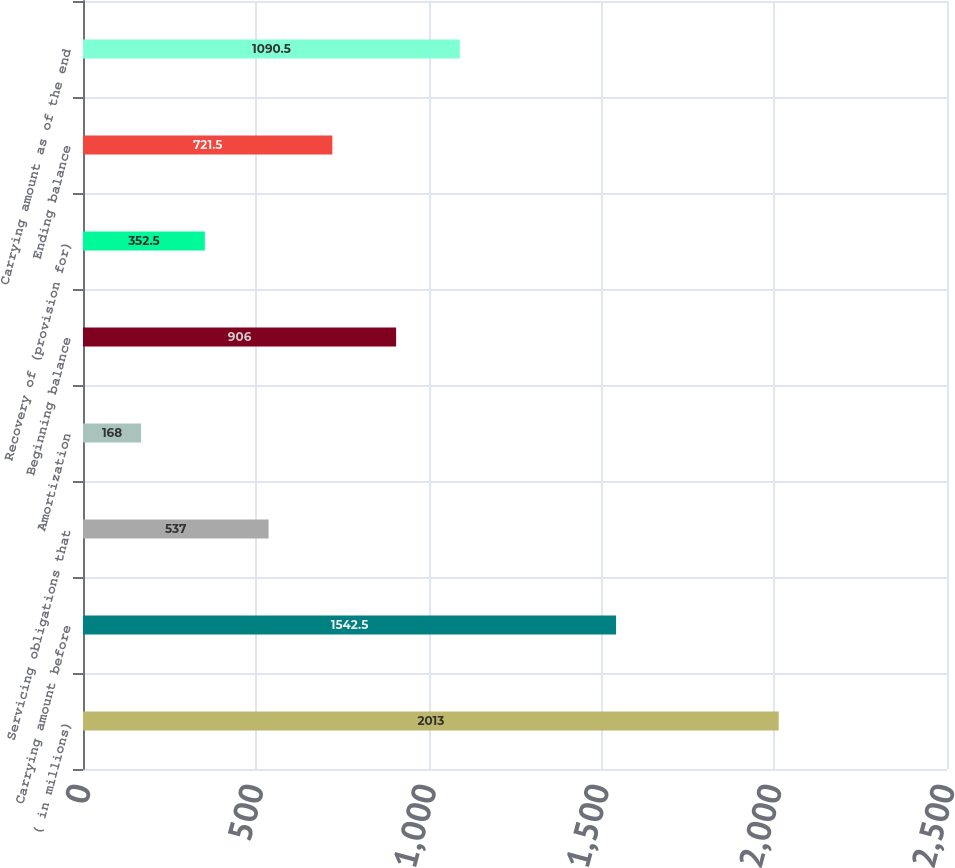Convert chart to OTSL. <chart><loc_0><loc_0><loc_500><loc_500><bar_chart><fcel>( in millions)<fcel>Carrying amount before<fcel>Servicing obligations that<fcel>Amortization<fcel>Beginning balance<fcel>Recovery of (provision for)<fcel>Ending balance<fcel>Carrying amount as of the end<nl><fcel>2013<fcel>1542.5<fcel>537<fcel>168<fcel>906<fcel>352.5<fcel>721.5<fcel>1090.5<nl></chart> 